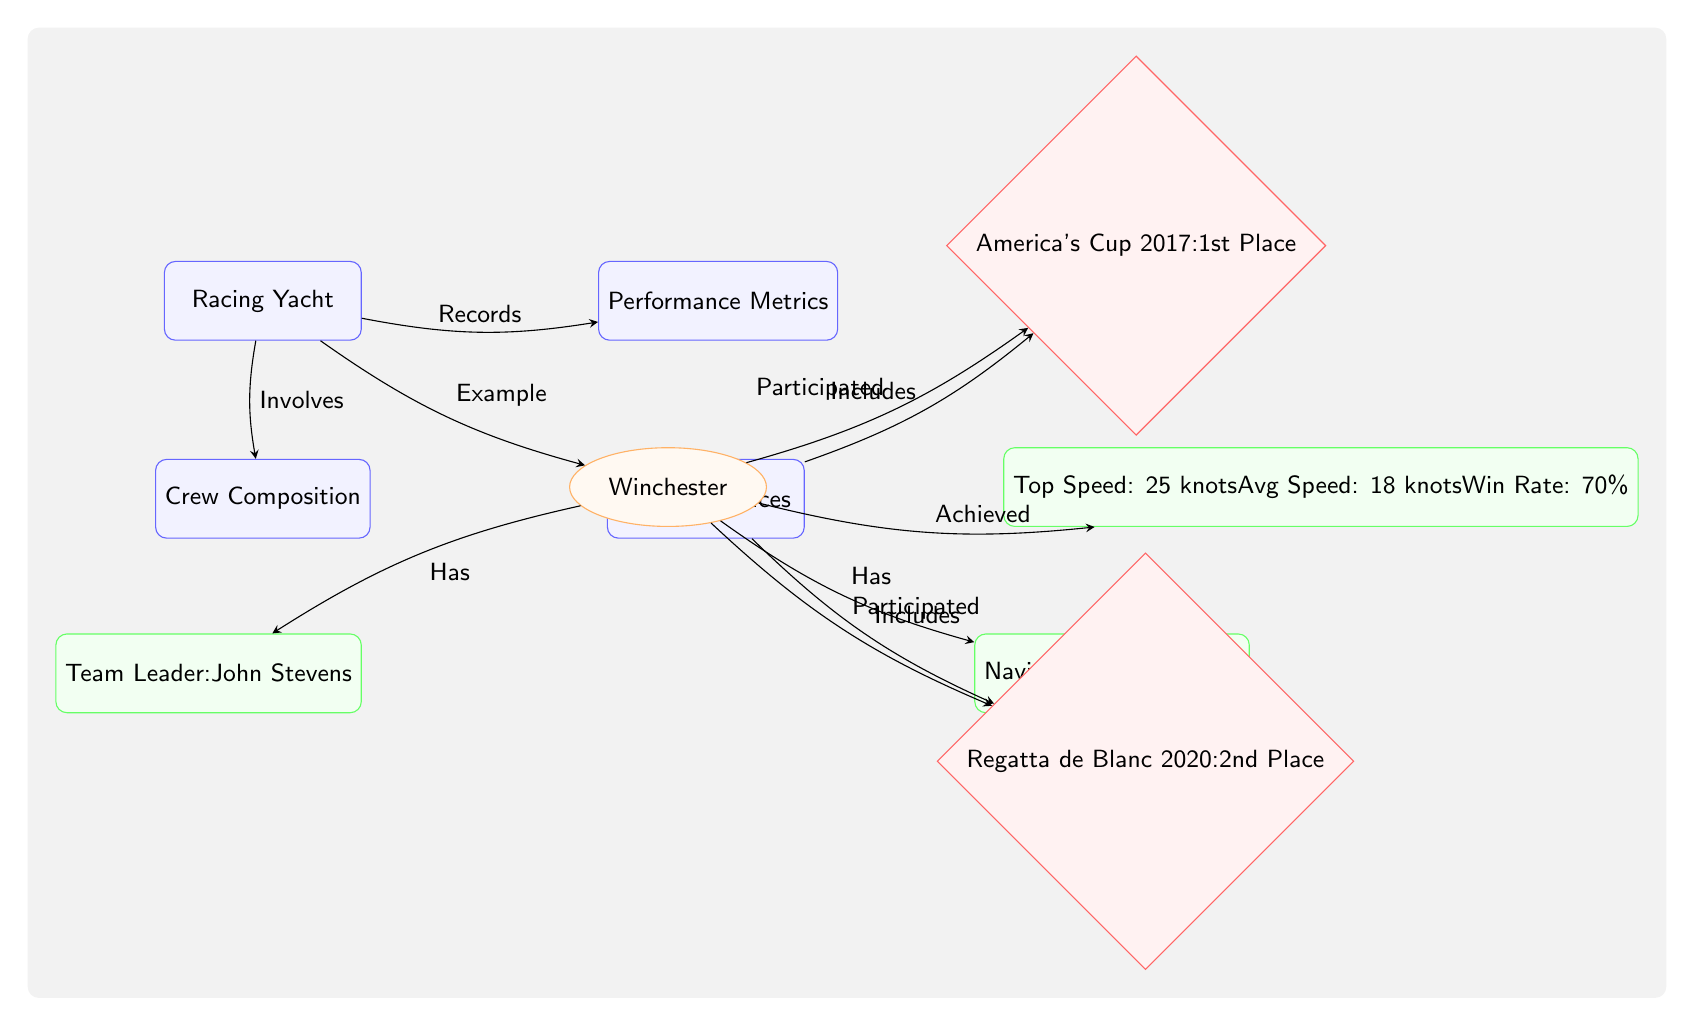What is the name of the example yacht? The diagram identifies "Winchester" as the example yacht within the racing yacht category.
Answer: Winchester Who is the team leader of the crew? In the diagram, "John Stevens" is identified as the Team Leader associated with the Winchester yacht.
Answer: John Stevens What is the win rate of the Winchester yacht? The performance metrics section shows that the win rate for the Winchester is stated as "70%."
Answer: 70% Which place did the Winchester achieve in the America's Cup 2017? The diagram indicates that the Winchester participated in the America's Cup 2017 and achieved "1st Place."
Answer: 1st Place How many historical races are listed in the diagram? The diagram shows two historical races, namely the America's Cup 2017 and Regatta de Blanc 2020, indicating there are two races listed.
Answer: 2 What is the top speed of the Winchester yacht? The performance metrics detail "Top Speed: 25 knots," representing the maximum speed achieved by the yacht.
Answer: 25 knots Which crew member is identified as the navigator? The diagram highlights "Emily Warner" as the navigator for the Winchester yacht alongside the team leader.
Answer: Emily Warner What is the average speed of the Winchester yacht? The performance metrics show that the average speed is indicated as "18 knots," representing the yacht's typical sailing speed.
Answer: 18 knots How does the Winchester yacht relate to crew composition? The diagram establishes a direct relationship stating that the Winchester yacht "Involves" crew composition, indicating reliance on the crew for performance.
Answer: Involves Which place did the Winchester achieve in the Regatta de Blanc 2020? The diagram states that the Winchester secured "2nd Place" in the Regatta de Blanc 2020, indicating the result of its participation in that event.
Answer: 2nd Place 